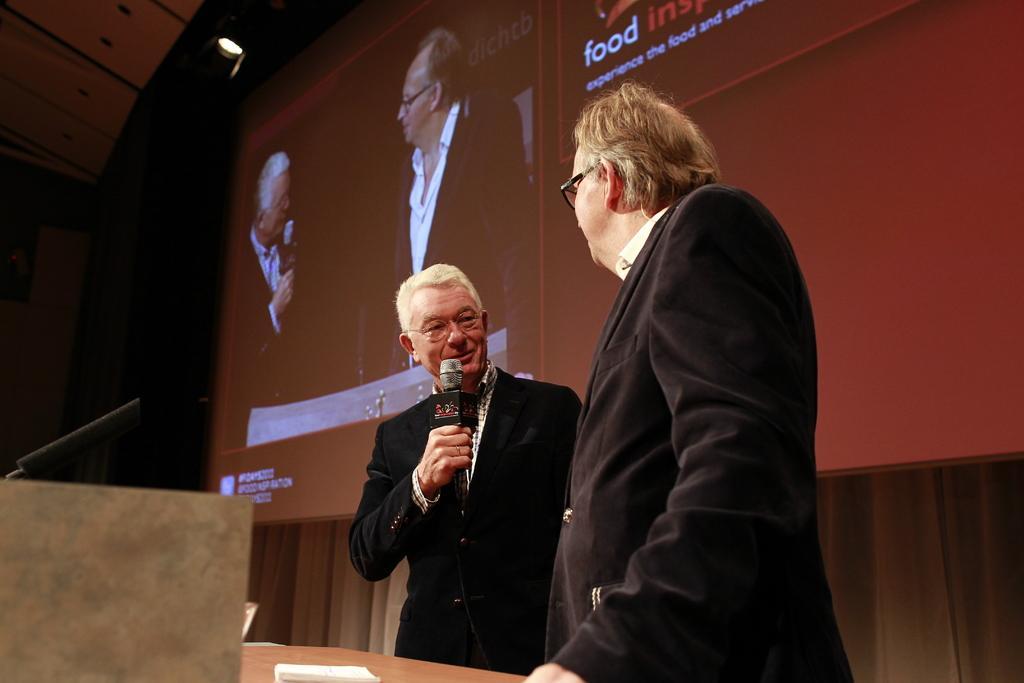In one or two sentences, can you explain what this image depicts? There are two man standing. One person is holding mike and speaking. This looks like a table with object on it. This is the screen with a display. This is the light at the top of the image. I think this is the cloth hanging at the background. I can see a black color object,I think this is the mike. 